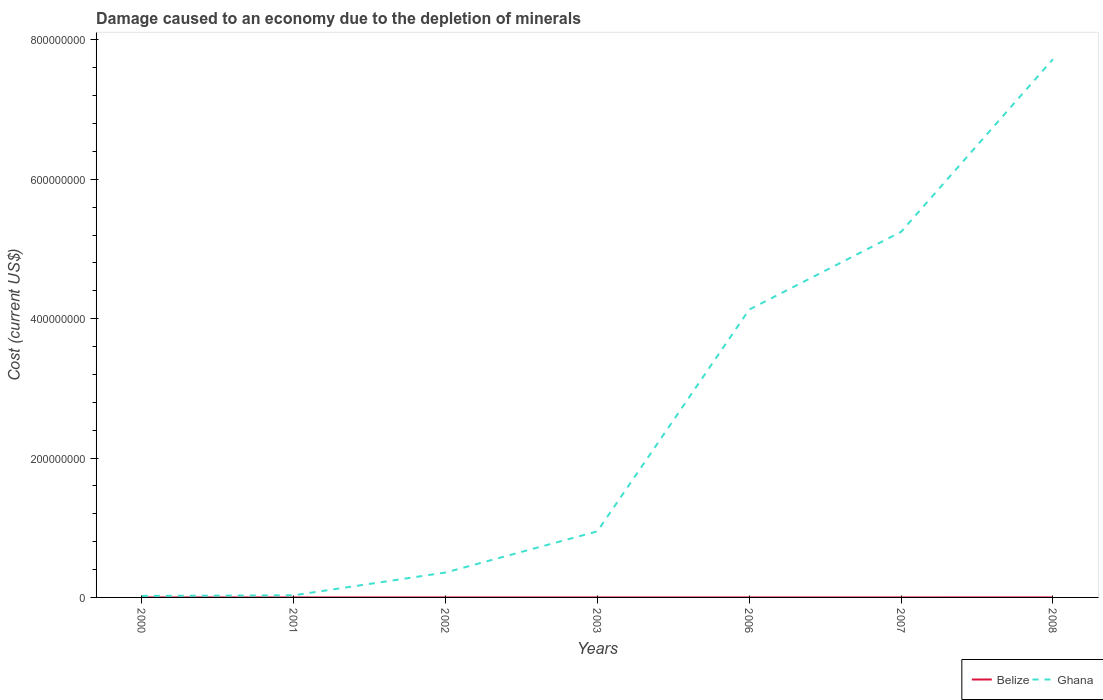Across all years, what is the maximum cost of damage caused due to the depletion of minerals in Belize?
Provide a short and direct response. 126.73. What is the total cost of damage caused due to the depletion of minerals in Belize in the graph?
Offer a terse response. -1387.12. What is the difference between the highest and the second highest cost of damage caused due to the depletion of minerals in Belize?
Make the answer very short. 5.55e+04. Is the cost of damage caused due to the depletion of minerals in Belize strictly greater than the cost of damage caused due to the depletion of minerals in Ghana over the years?
Keep it short and to the point. Yes. How many lines are there?
Your answer should be very brief. 2. What is the difference between two consecutive major ticks on the Y-axis?
Make the answer very short. 2.00e+08. How many legend labels are there?
Provide a succinct answer. 2. How are the legend labels stacked?
Offer a terse response. Horizontal. What is the title of the graph?
Keep it short and to the point. Damage caused to an economy due to the depletion of minerals. Does "Russian Federation" appear as one of the legend labels in the graph?
Your answer should be compact. No. What is the label or title of the Y-axis?
Your answer should be very brief. Cost (current US$). What is the Cost (current US$) of Belize in 2000?
Make the answer very short. 573.17. What is the Cost (current US$) of Ghana in 2000?
Keep it short and to the point. 2.16e+06. What is the Cost (current US$) of Belize in 2001?
Provide a succinct answer. 126.73. What is the Cost (current US$) of Ghana in 2001?
Offer a very short reply. 3.06e+06. What is the Cost (current US$) of Belize in 2002?
Your response must be concise. 1479.97. What is the Cost (current US$) of Ghana in 2002?
Offer a very short reply. 3.57e+07. What is the Cost (current US$) in Belize in 2003?
Your response must be concise. 1960.29. What is the Cost (current US$) of Ghana in 2003?
Your answer should be compact. 9.48e+07. What is the Cost (current US$) of Belize in 2006?
Offer a terse response. 2.10e+04. What is the Cost (current US$) in Ghana in 2006?
Provide a succinct answer. 4.13e+08. What is the Cost (current US$) of Belize in 2007?
Make the answer very short. 2.63e+04. What is the Cost (current US$) in Ghana in 2007?
Offer a terse response. 5.25e+08. What is the Cost (current US$) in Belize in 2008?
Provide a short and direct response. 5.57e+04. What is the Cost (current US$) in Ghana in 2008?
Make the answer very short. 7.72e+08. Across all years, what is the maximum Cost (current US$) in Belize?
Your answer should be compact. 5.57e+04. Across all years, what is the maximum Cost (current US$) in Ghana?
Offer a terse response. 7.72e+08. Across all years, what is the minimum Cost (current US$) in Belize?
Your response must be concise. 126.73. Across all years, what is the minimum Cost (current US$) in Ghana?
Ensure brevity in your answer.  2.16e+06. What is the total Cost (current US$) in Belize in the graph?
Offer a very short reply. 1.07e+05. What is the total Cost (current US$) of Ghana in the graph?
Your response must be concise. 1.85e+09. What is the difference between the Cost (current US$) in Belize in 2000 and that in 2001?
Your answer should be compact. 446.44. What is the difference between the Cost (current US$) of Ghana in 2000 and that in 2001?
Your answer should be very brief. -8.99e+05. What is the difference between the Cost (current US$) of Belize in 2000 and that in 2002?
Ensure brevity in your answer.  -906.8. What is the difference between the Cost (current US$) in Ghana in 2000 and that in 2002?
Your answer should be compact. -3.36e+07. What is the difference between the Cost (current US$) of Belize in 2000 and that in 2003?
Offer a terse response. -1387.12. What is the difference between the Cost (current US$) of Ghana in 2000 and that in 2003?
Provide a short and direct response. -9.27e+07. What is the difference between the Cost (current US$) of Belize in 2000 and that in 2006?
Provide a short and direct response. -2.05e+04. What is the difference between the Cost (current US$) in Ghana in 2000 and that in 2006?
Offer a terse response. -4.11e+08. What is the difference between the Cost (current US$) in Belize in 2000 and that in 2007?
Make the answer very short. -2.57e+04. What is the difference between the Cost (current US$) in Ghana in 2000 and that in 2007?
Your response must be concise. -5.22e+08. What is the difference between the Cost (current US$) in Belize in 2000 and that in 2008?
Make the answer very short. -5.51e+04. What is the difference between the Cost (current US$) in Ghana in 2000 and that in 2008?
Ensure brevity in your answer.  -7.70e+08. What is the difference between the Cost (current US$) in Belize in 2001 and that in 2002?
Your response must be concise. -1353.24. What is the difference between the Cost (current US$) of Ghana in 2001 and that in 2002?
Make the answer very short. -3.27e+07. What is the difference between the Cost (current US$) of Belize in 2001 and that in 2003?
Your answer should be very brief. -1833.56. What is the difference between the Cost (current US$) in Ghana in 2001 and that in 2003?
Keep it short and to the point. -9.18e+07. What is the difference between the Cost (current US$) in Belize in 2001 and that in 2006?
Your answer should be compact. -2.09e+04. What is the difference between the Cost (current US$) in Ghana in 2001 and that in 2006?
Offer a very short reply. -4.10e+08. What is the difference between the Cost (current US$) in Belize in 2001 and that in 2007?
Your answer should be compact. -2.62e+04. What is the difference between the Cost (current US$) in Ghana in 2001 and that in 2007?
Give a very brief answer. -5.22e+08. What is the difference between the Cost (current US$) of Belize in 2001 and that in 2008?
Provide a short and direct response. -5.55e+04. What is the difference between the Cost (current US$) of Ghana in 2001 and that in 2008?
Keep it short and to the point. -7.69e+08. What is the difference between the Cost (current US$) in Belize in 2002 and that in 2003?
Ensure brevity in your answer.  -480.32. What is the difference between the Cost (current US$) in Ghana in 2002 and that in 2003?
Offer a very short reply. -5.91e+07. What is the difference between the Cost (current US$) of Belize in 2002 and that in 2006?
Provide a succinct answer. -1.96e+04. What is the difference between the Cost (current US$) in Ghana in 2002 and that in 2006?
Your response must be concise. -3.77e+08. What is the difference between the Cost (current US$) in Belize in 2002 and that in 2007?
Provide a short and direct response. -2.48e+04. What is the difference between the Cost (current US$) of Ghana in 2002 and that in 2007?
Your answer should be very brief. -4.89e+08. What is the difference between the Cost (current US$) of Belize in 2002 and that in 2008?
Your answer should be very brief. -5.42e+04. What is the difference between the Cost (current US$) of Ghana in 2002 and that in 2008?
Make the answer very short. -7.37e+08. What is the difference between the Cost (current US$) in Belize in 2003 and that in 2006?
Give a very brief answer. -1.91e+04. What is the difference between the Cost (current US$) of Ghana in 2003 and that in 2006?
Offer a very short reply. -3.18e+08. What is the difference between the Cost (current US$) of Belize in 2003 and that in 2007?
Your response must be concise. -2.43e+04. What is the difference between the Cost (current US$) of Ghana in 2003 and that in 2007?
Your answer should be compact. -4.30e+08. What is the difference between the Cost (current US$) of Belize in 2003 and that in 2008?
Provide a short and direct response. -5.37e+04. What is the difference between the Cost (current US$) of Ghana in 2003 and that in 2008?
Your answer should be compact. -6.78e+08. What is the difference between the Cost (current US$) in Belize in 2006 and that in 2007?
Offer a terse response. -5266.77. What is the difference between the Cost (current US$) of Ghana in 2006 and that in 2007?
Ensure brevity in your answer.  -1.12e+08. What is the difference between the Cost (current US$) of Belize in 2006 and that in 2008?
Provide a short and direct response. -3.46e+04. What is the difference between the Cost (current US$) of Ghana in 2006 and that in 2008?
Provide a short and direct response. -3.59e+08. What is the difference between the Cost (current US$) in Belize in 2007 and that in 2008?
Your answer should be compact. -2.94e+04. What is the difference between the Cost (current US$) of Ghana in 2007 and that in 2008?
Ensure brevity in your answer.  -2.48e+08. What is the difference between the Cost (current US$) in Belize in 2000 and the Cost (current US$) in Ghana in 2001?
Keep it short and to the point. -3.06e+06. What is the difference between the Cost (current US$) of Belize in 2000 and the Cost (current US$) of Ghana in 2002?
Provide a short and direct response. -3.57e+07. What is the difference between the Cost (current US$) in Belize in 2000 and the Cost (current US$) in Ghana in 2003?
Provide a short and direct response. -9.48e+07. What is the difference between the Cost (current US$) in Belize in 2000 and the Cost (current US$) in Ghana in 2006?
Your answer should be very brief. -4.13e+08. What is the difference between the Cost (current US$) of Belize in 2000 and the Cost (current US$) of Ghana in 2007?
Your answer should be very brief. -5.25e+08. What is the difference between the Cost (current US$) in Belize in 2000 and the Cost (current US$) in Ghana in 2008?
Provide a succinct answer. -7.72e+08. What is the difference between the Cost (current US$) in Belize in 2001 and the Cost (current US$) in Ghana in 2002?
Keep it short and to the point. -3.57e+07. What is the difference between the Cost (current US$) of Belize in 2001 and the Cost (current US$) of Ghana in 2003?
Ensure brevity in your answer.  -9.48e+07. What is the difference between the Cost (current US$) of Belize in 2001 and the Cost (current US$) of Ghana in 2006?
Provide a succinct answer. -4.13e+08. What is the difference between the Cost (current US$) in Belize in 2001 and the Cost (current US$) in Ghana in 2007?
Your answer should be very brief. -5.25e+08. What is the difference between the Cost (current US$) of Belize in 2001 and the Cost (current US$) of Ghana in 2008?
Your answer should be very brief. -7.72e+08. What is the difference between the Cost (current US$) in Belize in 2002 and the Cost (current US$) in Ghana in 2003?
Your answer should be very brief. -9.48e+07. What is the difference between the Cost (current US$) in Belize in 2002 and the Cost (current US$) in Ghana in 2006?
Your response must be concise. -4.13e+08. What is the difference between the Cost (current US$) in Belize in 2002 and the Cost (current US$) in Ghana in 2007?
Your answer should be compact. -5.25e+08. What is the difference between the Cost (current US$) of Belize in 2002 and the Cost (current US$) of Ghana in 2008?
Make the answer very short. -7.72e+08. What is the difference between the Cost (current US$) of Belize in 2003 and the Cost (current US$) of Ghana in 2006?
Provide a succinct answer. -4.13e+08. What is the difference between the Cost (current US$) of Belize in 2003 and the Cost (current US$) of Ghana in 2007?
Your response must be concise. -5.25e+08. What is the difference between the Cost (current US$) of Belize in 2003 and the Cost (current US$) of Ghana in 2008?
Provide a short and direct response. -7.72e+08. What is the difference between the Cost (current US$) of Belize in 2006 and the Cost (current US$) of Ghana in 2007?
Make the answer very short. -5.25e+08. What is the difference between the Cost (current US$) of Belize in 2006 and the Cost (current US$) of Ghana in 2008?
Your answer should be compact. -7.72e+08. What is the difference between the Cost (current US$) in Belize in 2007 and the Cost (current US$) in Ghana in 2008?
Provide a succinct answer. -7.72e+08. What is the average Cost (current US$) in Belize per year?
Ensure brevity in your answer.  1.53e+04. What is the average Cost (current US$) of Ghana per year?
Your response must be concise. 2.64e+08. In the year 2000, what is the difference between the Cost (current US$) of Belize and Cost (current US$) of Ghana?
Provide a short and direct response. -2.16e+06. In the year 2001, what is the difference between the Cost (current US$) in Belize and Cost (current US$) in Ghana?
Your answer should be very brief. -3.06e+06. In the year 2002, what is the difference between the Cost (current US$) in Belize and Cost (current US$) in Ghana?
Offer a terse response. -3.57e+07. In the year 2003, what is the difference between the Cost (current US$) of Belize and Cost (current US$) of Ghana?
Offer a very short reply. -9.48e+07. In the year 2006, what is the difference between the Cost (current US$) of Belize and Cost (current US$) of Ghana?
Your answer should be compact. -4.13e+08. In the year 2007, what is the difference between the Cost (current US$) of Belize and Cost (current US$) of Ghana?
Your answer should be very brief. -5.25e+08. In the year 2008, what is the difference between the Cost (current US$) in Belize and Cost (current US$) in Ghana?
Your answer should be very brief. -7.72e+08. What is the ratio of the Cost (current US$) in Belize in 2000 to that in 2001?
Your response must be concise. 4.52. What is the ratio of the Cost (current US$) in Ghana in 2000 to that in 2001?
Offer a terse response. 0.71. What is the ratio of the Cost (current US$) of Belize in 2000 to that in 2002?
Your answer should be very brief. 0.39. What is the ratio of the Cost (current US$) of Ghana in 2000 to that in 2002?
Provide a short and direct response. 0.06. What is the ratio of the Cost (current US$) in Belize in 2000 to that in 2003?
Your answer should be compact. 0.29. What is the ratio of the Cost (current US$) in Ghana in 2000 to that in 2003?
Your answer should be very brief. 0.02. What is the ratio of the Cost (current US$) of Belize in 2000 to that in 2006?
Offer a very short reply. 0.03. What is the ratio of the Cost (current US$) in Ghana in 2000 to that in 2006?
Provide a short and direct response. 0.01. What is the ratio of the Cost (current US$) in Belize in 2000 to that in 2007?
Your response must be concise. 0.02. What is the ratio of the Cost (current US$) in Ghana in 2000 to that in 2007?
Your response must be concise. 0. What is the ratio of the Cost (current US$) in Belize in 2000 to that in 2008?
Provide a short and direct response. 0.01. What is the ratio of the Cost (current US$) in Ghana in 2000 to that in 2008?
Keep it short and to the point. 0. What is the ratio of the Cost (current US$) of Belize in 2001 to that in 2002?
Your answer should be compact. 0.09. What is the ratio of the Cost (current US$) in Ghana in 2001 to that in 2002?
Make the answer very short. 0.09. What is the ratio of the Cost (current US$) of Belize in 2001 to that in 2003?
Provide a short and direct response. 0.06. What is the ratio of the Cost (current US$) in Ghana in 2001 to that in 2003?
Your answer should be very brief. 0.03. What is the ratio of the Cost (current US$) of Belize in 2001 to that in 2006?
Ensure brevity in your answer.  0.01. What is the ratio of the Cost (current US$) of Ghana in 2001 to that in 2006?
Make the answer very short. 0.01. What is the ratio of the Cost (current US$) in Belize in 2001 to that in 2007?
Ensure brevity in your answer.  0. What is the ratio of the Cost (current US$) of Ghana in 2001 to that in 2007?
Offer a terse response. 0.01. What is the ratio of the Cost (current US$) in Belize in 2001 to that in 2008?
Keep it short and to the point. 0. What is the ratio of the Cost (current US$) of Ghana in 2001 to that in 2008?
Provide a succinct answer. 0. What is the ratio of the Cost (current US$) in Belize in 2002 to that in 2003?
Your answer should be very brief. 0.76. What is the ratio of the Cost (current US$) of Ghana in 2002 to that in 2003?
Provide a short and direct response. 0.38. What is the ratio of the Cost (current US$) of Belize in 2002 to that in 2006?
Keep it short and to the point. 0.07. What is the ratio of the Cost (current US$) in Ghana in 2002 to that in 2006?
Ensure brevity in your answer.  0.09. What is the ratio of the Cost (current US$) of Belize in 2002 to that in 2007?
Provide a succinct answer. 0.06. What is the ratio of the Cost (current US$) of Ghana in 2002 to that in 2007?
Your answer should be very brief. 0.07. What is the ratio of the Cost (current US$) in Belize in 2002 to that in 2008?
Your response must be concise. 0.03. What is the ratio of the Cost (current US$) in Ghana in 2002 to that in 2008?
Offer a very short reply. 0.05. What is the ratio of the Cost (current US$) of Belize in 2003 to that in 2006?
Provide a succinct answer. 0.09. What is the ratio of the Cost (current US$) in Ghana in 2003 to that in 2006?
Your answer should be compact. 0.23. What is the ratio of the Cost (current US$) of Belize in 2003 to that in 2007?
Offer a terse response. 0.07. What is the ratio of the Cost (current US$) of Ghana in 2003 to that in 2007?
Ensure brevity in your answer.  0.18. What is the ratio of the Cost (current US$) in Belize in 2003 to that in 2008?
Provide a succinct answer. 0.04. What is the ratio of the Cost (current US$) of Ghana in 2003 to that in 2008?
Your answer should be very brief. 0.12. What is the ratio of the Cost (current US$) of Belize in 2006 to that in 2007?
Provide a succinct answer. 0.8. What is the ratio of the Cost (current US$) in Ghana in 2006 to that in 2007?
Your response must be concise. 0.79. What is the ratio of the Cost (current US$) in Belize in 2006 to that in 2008?
Keep it short and to the point. 0.38. What is the ratio of the Cost (current US$) in Ghana in 2006 to that in 2008?
Provide a succinct answer. 0.53. What is the ratio of the Cost (current US$) of Belize in 2007 to that in 2008?
Provide a short and direct response. 0.47. What is the ratio of the Cost (current US$) of Ghana in 2007 to that in 2008?
Keep it short and to the point. 0.68. What is the difference between the highest and the second highest Cost (current US$) of Belize?
Ensure brevity in your answer.  2.94e+04. What is the difference between the highest and the second highest Cost (current US$) of Ghana?
Make the answer very short. 2.48e+08. What is the difference between the highest and the lowest Cost (current US$) of Belize?
Your answer should be compact. 5.55e+04. What is the difference between the highest and the lowest Cost (current US$) in Ghana?
Keep it short and to the point. 7.70e+08. 